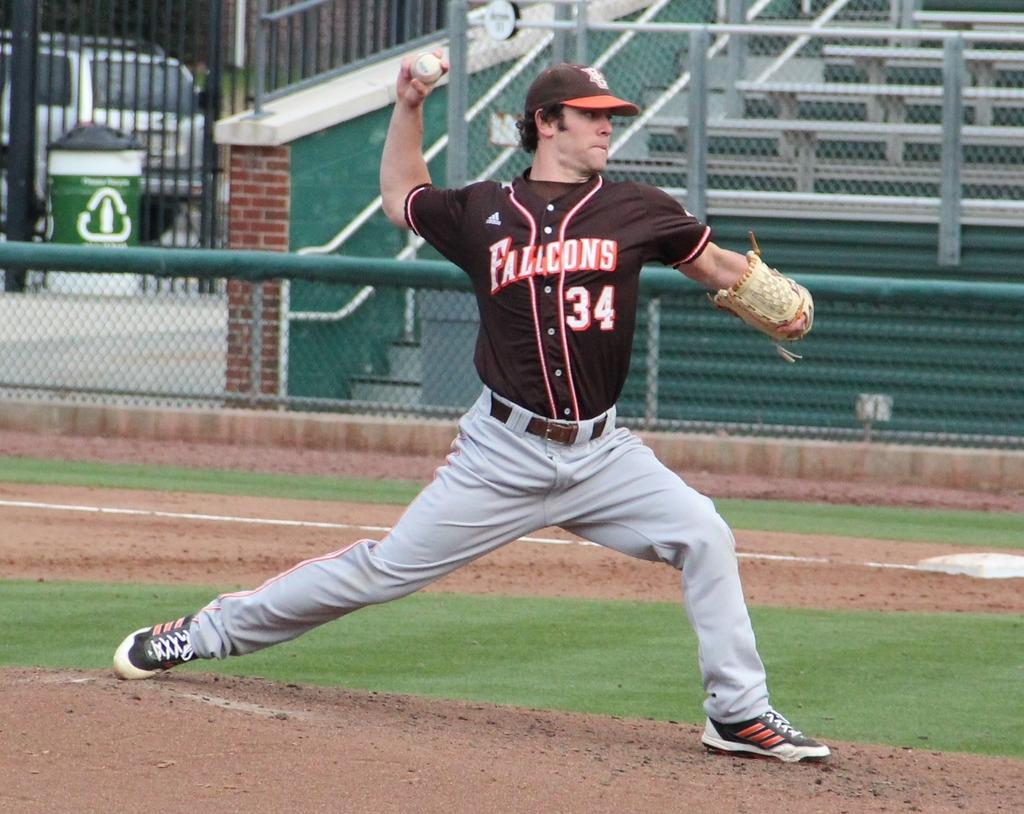Provide a one-sentence caption for the provided image. Player number 34 for the Flacons throws a pitch. 